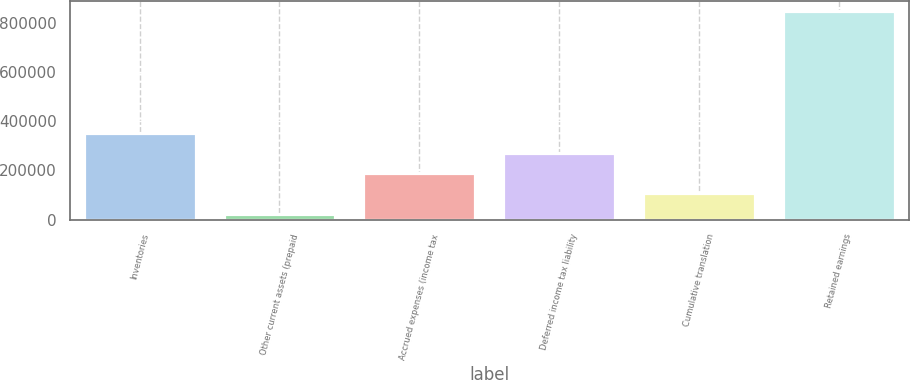Convert chart. <chart><loc_0><loc_0><loc_500><loc_500><bar_chart><fcel>Inventories<fcel>Other current assets (prepaid<fcel>Accrued expenses (income tax<fcel>Deferred income tax liability<fcel>Cumulative translation<fcel>Retained earnings<nl><fcel>352812<fcel>24423<fcel>188618<fcel>270715<fcel>106520<fcel>845396<nl></chart> 